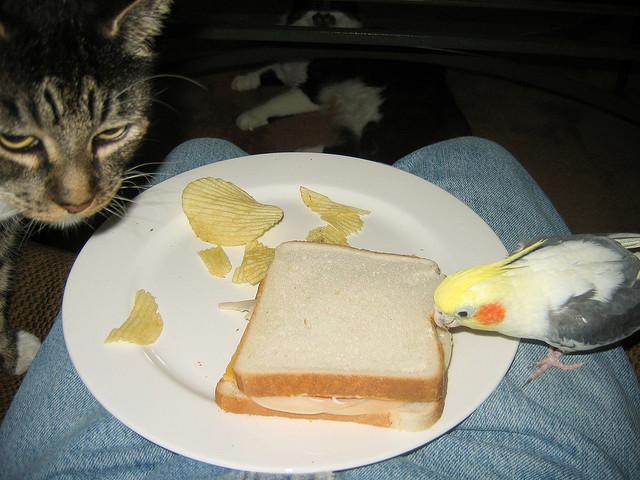Do cats and birds usually share meals?
Concise answer only. No. Are there chips?
Quick response, please. Yes. What is on the sandwich?
Quick response, please. Meat. 